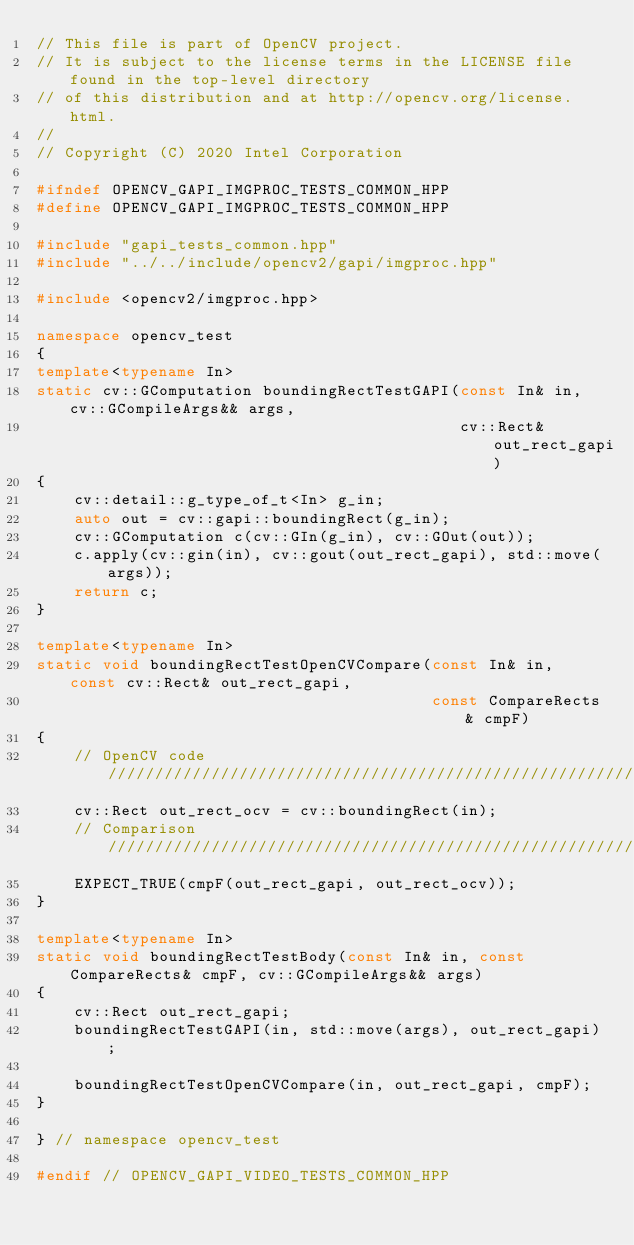<code> <loc_0><loc_0><loc_500><loc_500><_C++_>// This file is part of OpenCV project.
// It is subject to the license terms in the LICENSE file found in the top-level directory
// of this distribution and at http://opencv.org/license.html.
//
// Copyright (C) 2020 Intel Corporation

#ifndef OPENCV_GAPI_IMGPROC_TESTS_COMMON_HPP
#define OPENCV_GAPI_IMGPROC_TESTS_COMMON_HPP

#include "gapi_tests_common.hpp"
#include "../../include/opencv2/gapi/imgproc.hpp"

#include <opencv2/imgproc.hpp>

namespace opencv_test
{
template<typename In>
static cv::GComputation boundingRectTestGAPI(const In& in, cv::GCompileArgs&& args,
                                             cv::Rect& out_rect_gapi)
{
    cv::detail::g_type_of_t<In> g_in;
    auto out = cv::gapi::boundingRect(g_in);
    cv::GComputation c(cv::GIn(g_in), cv::GOut(out));
    c.apply(cv::gin(in), cv::gout(out_rect_gapi), std::move(args));
    return c;
}

template<typename In>
static void boundingRectTestOpenCVCompare(const In& in, const cv::Rect& out_rect_gapi,
                                          const CompareRects& cmpF)
{
    // OpenCV code /////////////////////////////////////////////////////////////
    cv::Rect out_rect_ocv = cv::boundingRect(in);
    // Comparison //////////////////////////////////////////////////////////////
    EXPECT_TRUE(cmpF(out_rect_gapi, out_rect_ocv));
}

template<typename In>
static void boundingRectTestBody(const In& in, const CompareRects& cmpF, cv::GCompileArgs&& args)
{
    cv::Rect out_rect_gapi;
    boundingRectTestGAPI(in, std::move(args), out_rect_gapi);

    boundingRectTestOpenCVCompare(in, out_rect_gapi, cmpF);
}

} // namespace opencv_test

#endif // OPENCV_GAPI_VIDEO_TESTS_COMMON_HPP
</code> 